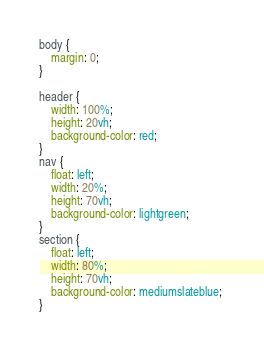<code> <loc_0><loc_0><loc_500><loc_500><_CSS_>body {
    margin: 0;
}

header {
    width: 100%;
    height: 20vh;
    background-color: red;
}
nav {
    float: left;
    width: 20%;
    height: 70vh;
    background-color: lightgreen; 
}
section {
    float: left;
    width: 80%;
    height: 70vh;
    background-color: mediumslateblue; 
}
</code> 